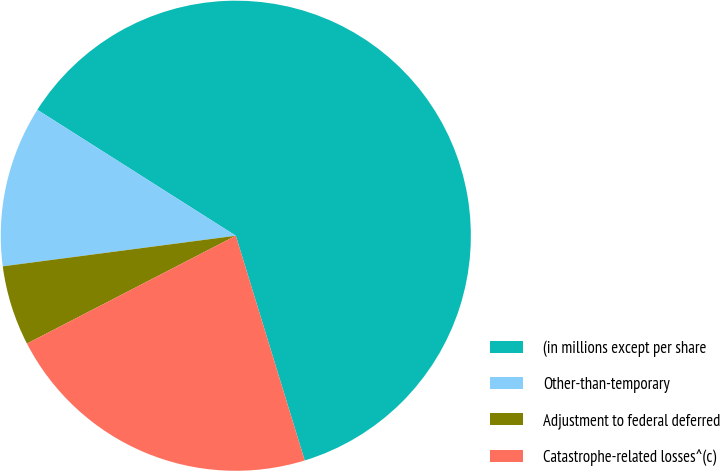Convert chart to OTSL. <chart><loc_0><loc_0><loc_500><loc_500><pie_chart><fcel>(in millions except per share<fcel>Other-than-temporary<fcel>Adjustment to federal deferred<fcel>Catastrophe-related losses^(c)<nl><fcel>61.27%<fcel>11.08%<fcel>5.51%<fcel>22.15%<nl></chart> 